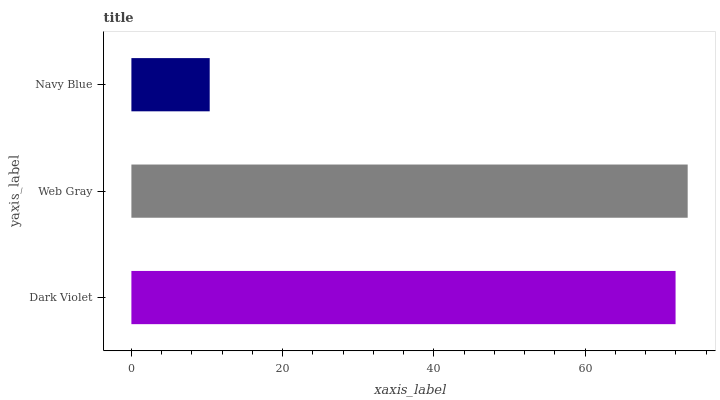Is Navy Blue the minimum?
Answer yes or no. Yes. Is Web Gray the maximum?
Answer yes or no. Yes. Is Web Gray the minimum?
Answer yes or no. No. Is Navy Blue the maximum?
Answer yes or no. No. Is Web Gray greater than Navy Blue?
Answer yes or no. Yes. Is Navy Blue less than Web Gray?
Answer yes or no. Yes. Is Navy Blue greater than Web Gray?
Answer yes or no. No. Is Web Gray less than Navy Blue?
Answer yes or no. No. Is Dark Violet the high median?
Answer yes or no. Yes. Is Dark Violet the low median?
Answer yes or no. Yes. Is Web Gray the high median?
Answer yes or no. No. Is Web Gray the low median?
Answer yes or no. No. 